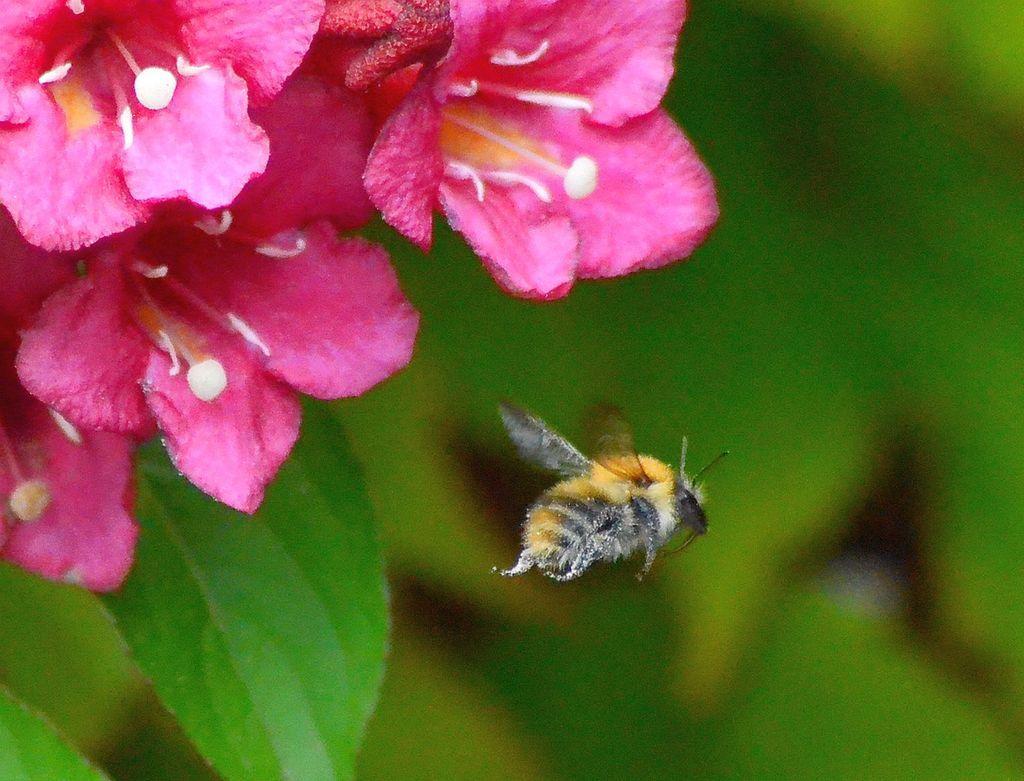How would you summarize this image in a sentence or two? There are flowers and a bee in the foreground area of the image and the background is blurry. 